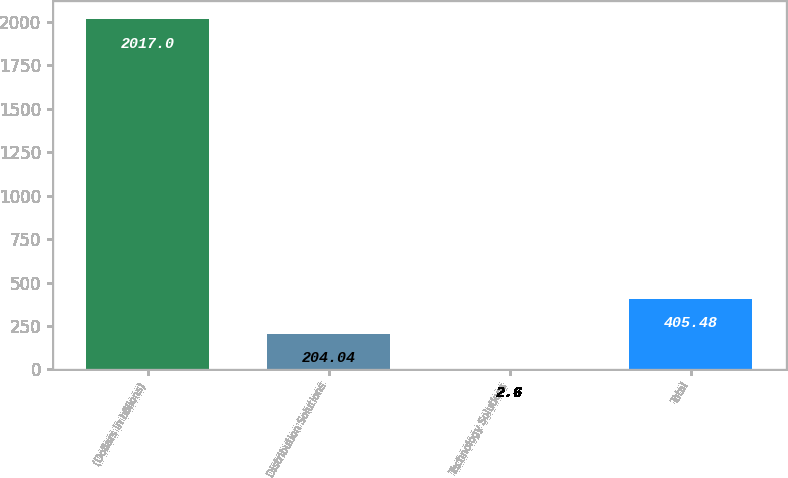Convert chart to OTSL. <chart><loc_0><loc_0><loc_500><loc_500><bar_chart><fcel>(Dollars in billions)<fcel>Distribution Solutions<fcel>Technology Solutions<fcel>Total<nl><fcel>2017<fcel>204.04<fcel>2.6<fcel>405.48<nl></chart> 